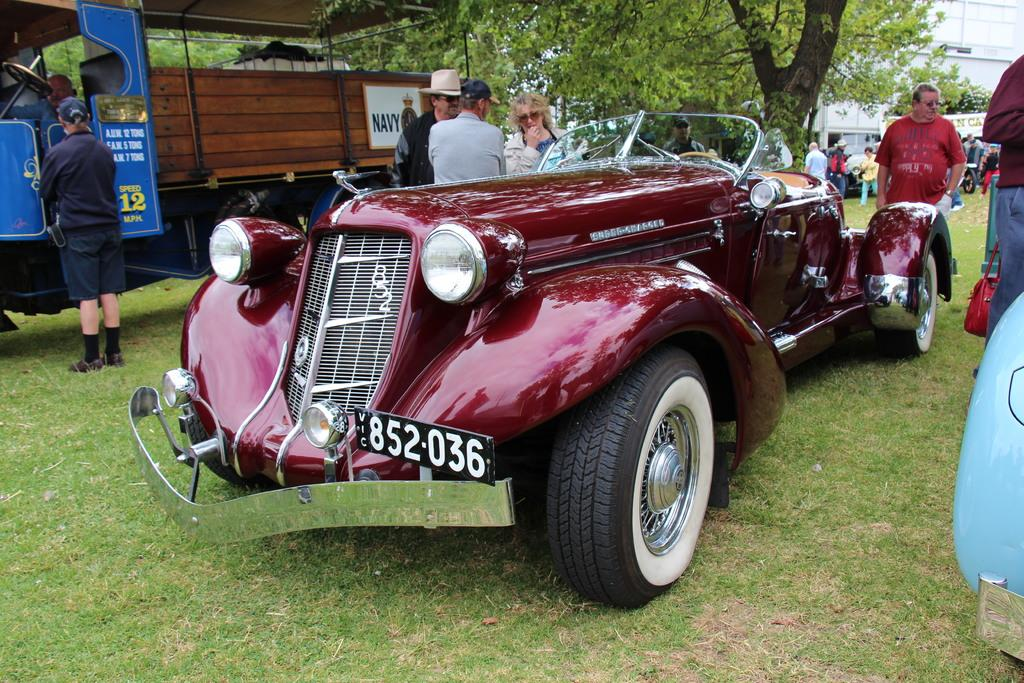What type of vehicles can be seen in the image? There is a car and a truck in the image. Are there any people present in the image? Yes, there are people in the image. What type of natural environment is visible in the image? There is grass visible in the image. What type of man-made structures can be seen in the image? There are buildings in the image. What type of plant is present in the image? There is a tree in the image. What type of cable is being used to cook the stew in the image? There is no cable or stew present in the image. Can you describe the insect that is sitting on the car in the image? There is no insect present on the car in the image. 